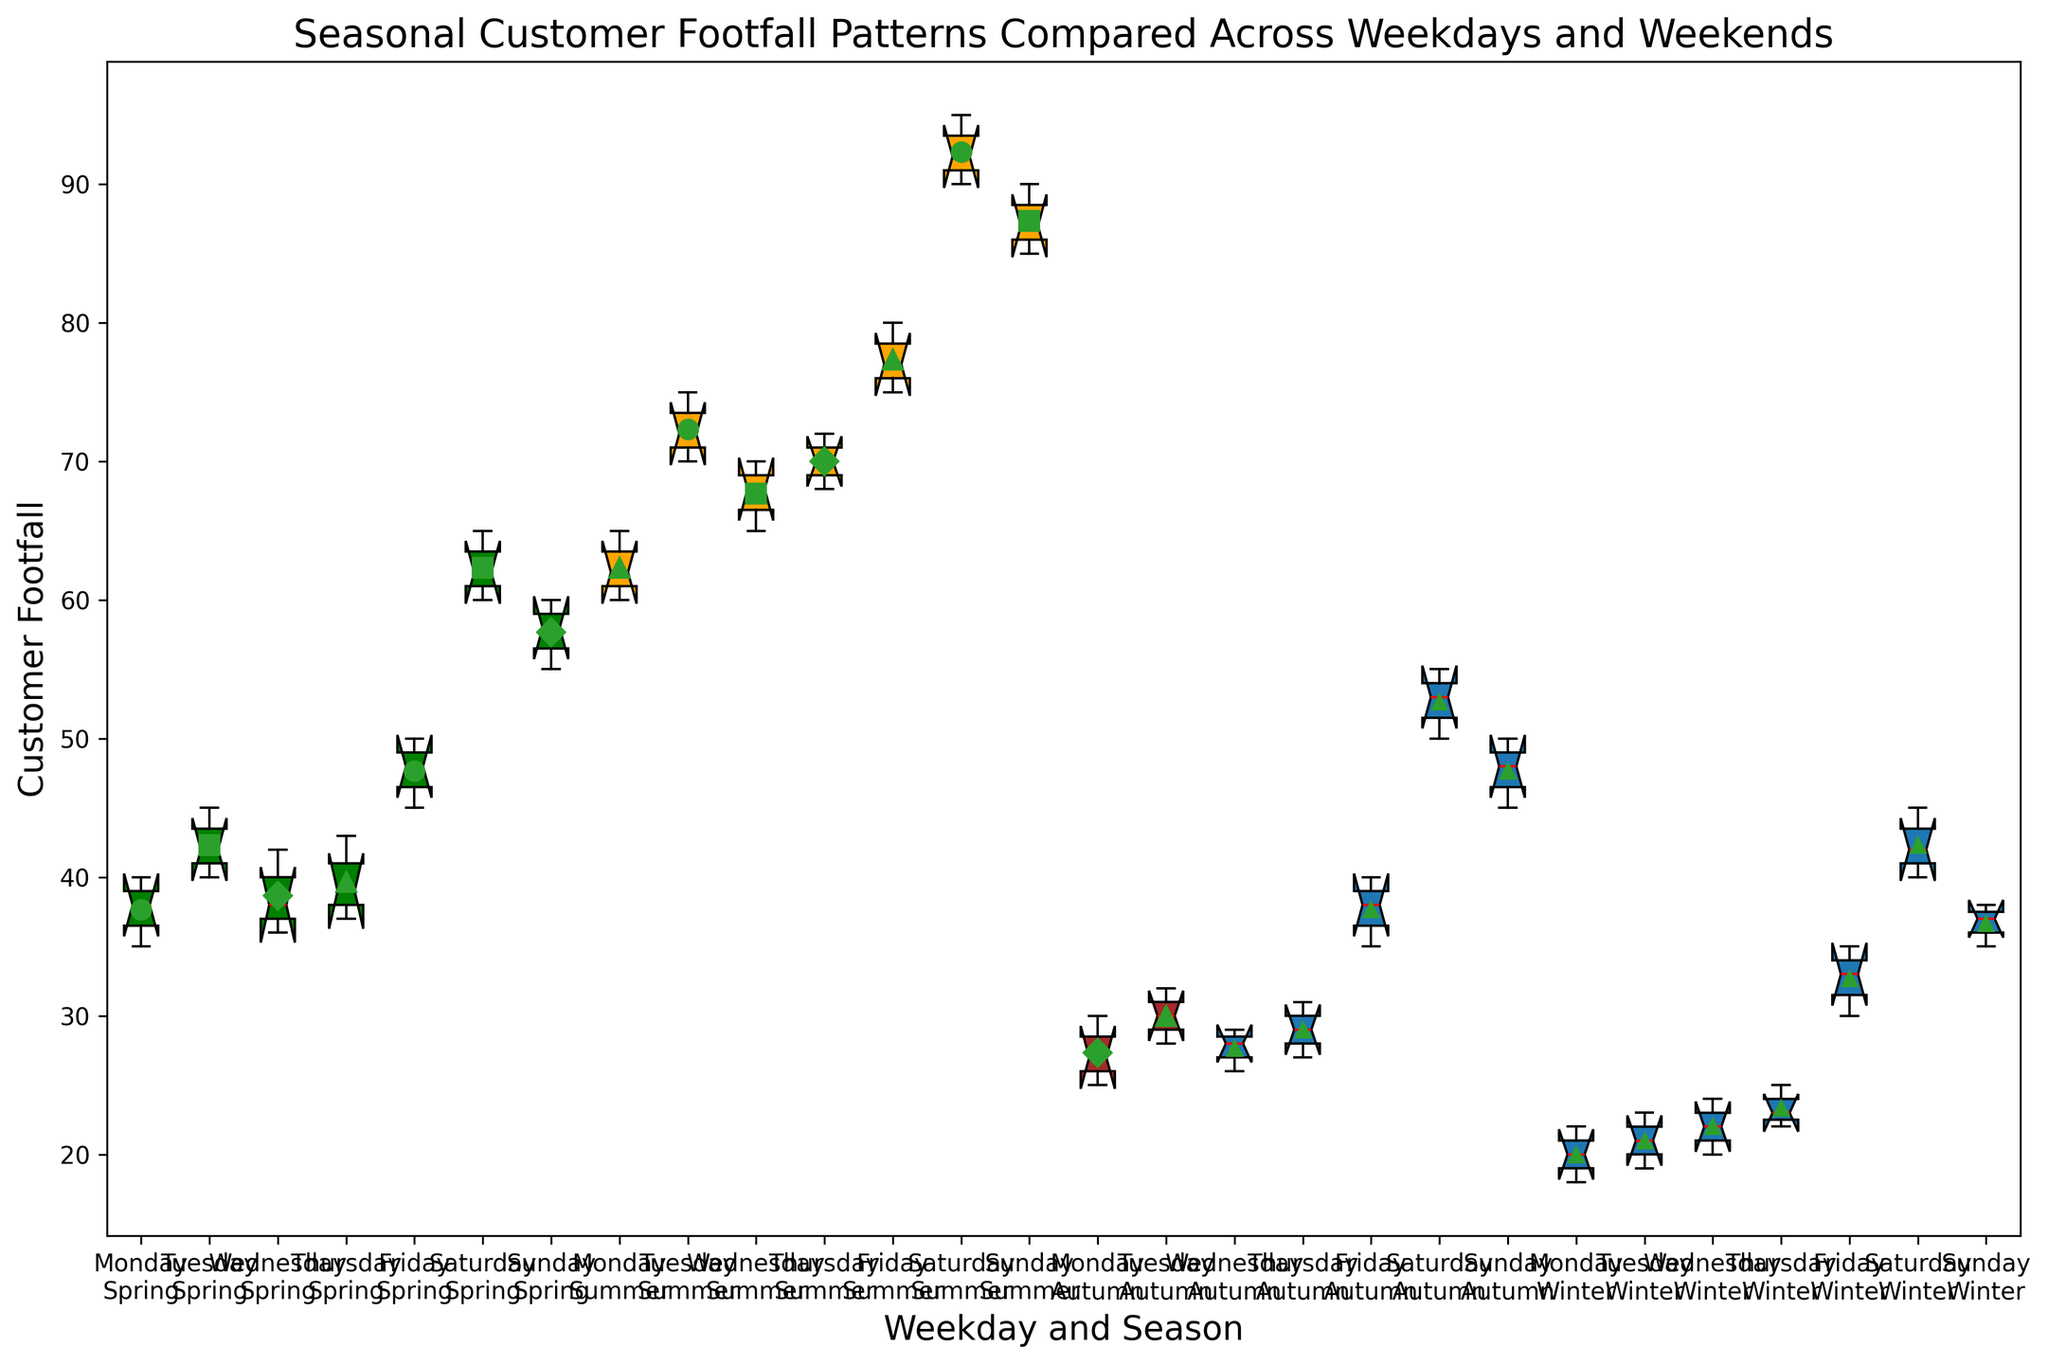Which season generally shows the highest customer footfall? By looking at the vertical span of the data points, we observe that the boxes representing Summer have higher footfall values in general compared to other seasons. This is particularly visible for both weekdays and weekends.
Answer: Summer What is the median customer footfall for Saturdays during Winter? Saturday in Winter is marked by the annotated line in the middle of the corresponding box plot. The line inside the box plot for Saturday in Winter is just below 45, indicating the median.
Answer: Just below 45 Which day and season combination shows the least variation in customer footfall? Variation is depicted by the height of the box plot. The smaller the height, the lesser the variation. By examining the height of all box plots, it is evident that Monday in Autumn shows the least variation.
Answer: Monday in Autumn Compare the average customer footfall between Fridays and Sundays during Summer. The average can be inferred from the means marked in the plot. For Fridays during Summer, the mean is in the middle, closer to 77. For Sundays during Summer, the mean is around 87. Comparing these mean values shows that Sundays have a higher average footfall.
Answer: Sundays (Summer) have a higher average Is the customer footfall on Tuesdays in Autumn higher or lower compared to Thursdays in Spring? By looking at the position of the medians, Tuesdays in Autumn have a median around 30, whereas, Thursdays in Spring have a median around 39. This shows that Thursdays in Spring have a higher footfall.
Answer: Lower on Tuesdays in Autumn What is the color representing Winter? The visual attribute concerning color shows that Winter boxes are colored blue.
Answer: Blue Which weekday during Spring has the highest median customer footfall? From the Spring section of the plot, we observe that Friday has the highest median marked by the line inside the box plot, which is around 50.
Answer: Friday On which day does the customer footfall exhibit the highest median footfall during Autumn? By observing the box plots for Autumn, Saturday has the highest median, which is indicated around 53.
Answer: Saturday Does customer footfall on Saturdays during Winter have a higher median value than that on Wednesdays during Winter? By observing the medians, Saturday during Winter shows a median just under 45, whereas Wednesday in Winter shows around 22. This indicates that the median is higher on Saturday.
Answer: Yes, higher on Saturday Compare the overall variation in customer footfall for weekdays versus weekends during Summer. Weekdays (Monday to Friday) and weekends (Saturday and Sunday) in Summer can be compared by looking at the height of the boxes. The boxes for weekdays are smaller in height compared to weekends, showing that weekends have higher variation.
Answer: Weekends have higher variation 